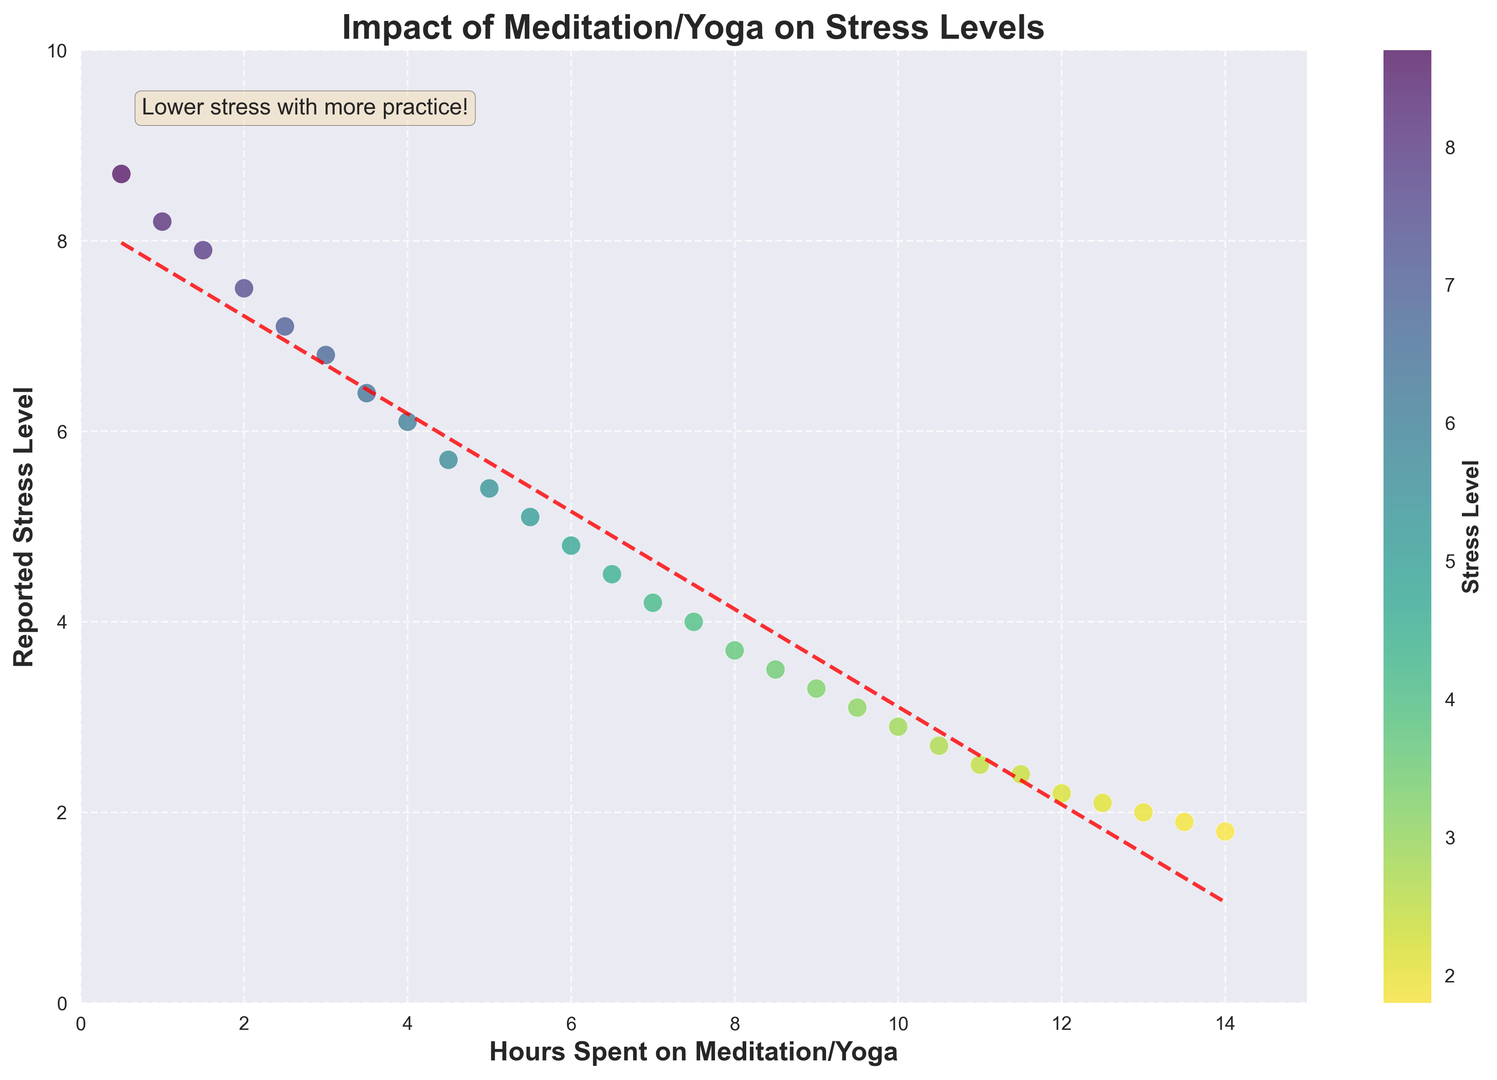What is the trend shown between hours spent on meditation/yoga and reported stress levels? The scatter plot and the trend line indicate that as the hours spent on meditation/yoga increase, the reported stress levels tend to decrease. The scatter points create a downward trend from left to right, and the red dashed trend line confirms this relationship.
Answer: As hours increase, stress levels decrease Which hour of meditation/yoga corresponds to the highest reported stress level? The highest reported stress level appears at the point with the lowest hours of meditation/yoga. From the scatter plot, the highest reported stress level is around 8.7, which corresponds to 0.5 hours of meditation/yoga.
Answer: 0.5 hours If someone spends 7 hours on meditation/yoga, what is their approximate reported stress level? By referring to the scatter plot, you can locate the point where 7 hours meet the trend of the scatter points. The point is at approximately a stress level of 4.2.
Answer: 4.2 What is the approximate reported stress level for someone who spends 12 hours on meditation/yoga? In the scatter plot, you can find the point corresponding to 12 hours of meditation/yoga and see where it aligns with the reported stress level, which is approximately 2.2.
Answer: 2.2 Compare the reported stress levels between someone who spends 3 hours on meditation/yoga and someone who spends 6 hours. By locating the points for 3 hours and 6 hours on the scatter plot, we notice that the stress level for 3 hours is around 6.8, and for 6 hours, it is around 4.8, indicating a decrease of 2.0 stress levels.
Answer: 6.8 vs 4.8 What is the effect of increasing meditation/yoga from 4 to 10 hours on reported stress levels? By comparing the points at 4 hours and 10 hours on the scatter plot, the stress level decreases from approximately 6.1 to 2.9, resulting in a reduction of about 3.2 stress levels.
Answer: Stress reduces by 3.2 At what point does the trend line cross the 5 stress level mark? By observing the intersection of the red dashed trend line with the horizontal line at 5 on the scatter plot, you can see that this crossing happens at about 5.5 hours of meditation/yoga.
Answer: 5.5 hours What is the color shift in the scatter plot as stress levels decrease? The color bar shows the gradient from high to low stress levels, transforming from a darker color for higher stress levels to a lighter color for lower stress levels.
Answer: Darker to lighter How does the annotation on the plot help interpret the data? The annotation "Lower stress with more practice!" at the top left of the plot underlines the observed trend that increasing meditation/yoga hours reduce stress levels, providing an encouraging summary of the data.
Answer: Highlights trend By how much does the reported stress level decrease on average per hour of additional meditation/yoga, based on the trend line? The slope of the trend line in the scatter plot captures the average decrease. Fitting a linear trend line shows a slope of approximately -0.5, meaning that each added hour of meditation/yoga reduces stress levels by an average of 0.5 units.
Answer: Approximately 0.5 units per hour 